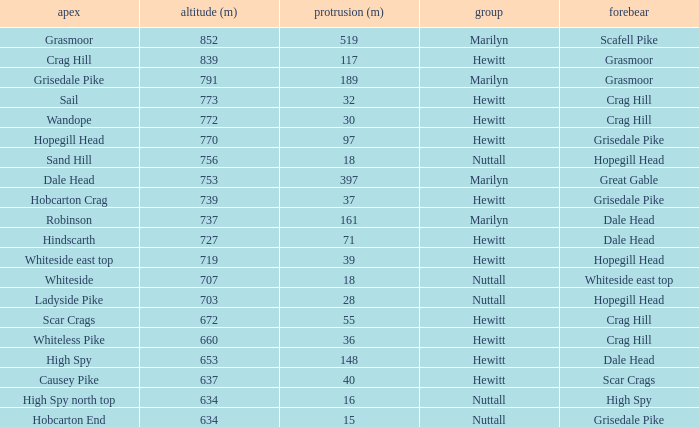Give me the full table as a dictionary. {'header': ['apex', 'altitude (m)', 'protrusion (m)', 'group', 'forebear'], 'rows': [['Grasmoor', '852', '519', 'Marilyn', 'Scafell Pike'], ['Crag Hill', '839', '117', 'Hewitt', 'Grasmoor'], ['Grisedale Pike', '791', '189', 'Marilyn', 'Grasmoor'], ['Sail', '773', '32', 'Hewitt', 'Crag Hill'], ['Wandope', '772', '30', 'Hewitt', 'Crag Hill'], ['Hopegill Head', '770', '97', 'Hewitt', 'Grisedale Pike'], ['Sand Hill', '756', '18', 'Nuttall', 'Hopegill Head'], ['Dale Head', '753', '397', 'Marilyn', 'Great Gable'], ['Hobcarton Crag', '739', '37', 'Hewitt', 'Grisedale Pike'], ['Robinson', '737', '161', 'Marilyn', 'Dale Head'], ['Hindscarth', '727', '71', 'Hewitt', 'Dale Head'], ['Whiteside east top', '719', '39', 'Hewitt', 'Hopegill Head'], ['Whiteside', '707', '18', 'Nuttall', 'Whiteside east top'], ['Ladyside Pike', '703', '28', 'Nuttall', 'Hopegill Head'], ['Scar Crags', '672', '55', 'Hewitt', 'Crag Hill'], ['Whiteless Pike', '660', '36', 'Hewitt', 'Crag Hill'], ['High Spy', '653', '148', 'Hewitt', 'Dale Head'], ['Causey Pike', '637', '40', 'Hewitt', 'Scar Crags'], ['High Spy north top', '634', '16', 'Nuttall', 'High Spy'], ['Hobcarton End', '634', '15', 'Nuttall', 'Grisedale Pike']]} Which Parent has height smaller than 756 and a Prom of 39? Hopegill Head. 